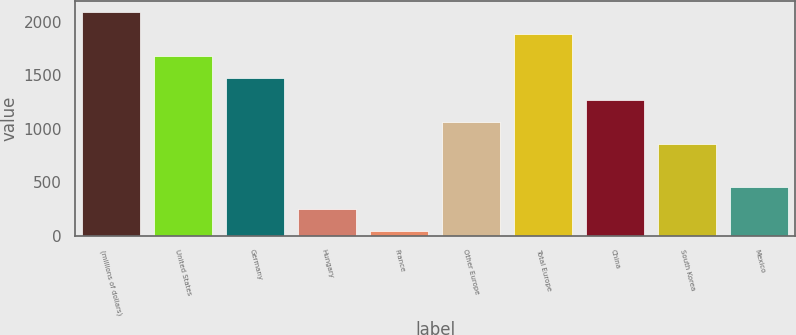Convert chart. <chart><loc_0><loc_0><loc_500><loc_500><bar_chart><fcel>(millions of dollars)<fcel>United States<fcel>Germany<fcel>Hungary<fcel>France<fcel>Other Europe<fcel>Total Europe<fcel>China<fcel>South Korea<fcel>Mexico<nl><fcel>2093.9<fcel>1683.62<fcel>1478.48<fcel>247.64<fcel>42.5<fcel>1068.2<fcel>1888.76<fcel>1273.34<fcel>863.06<fcel>452.78<nl></chart> 